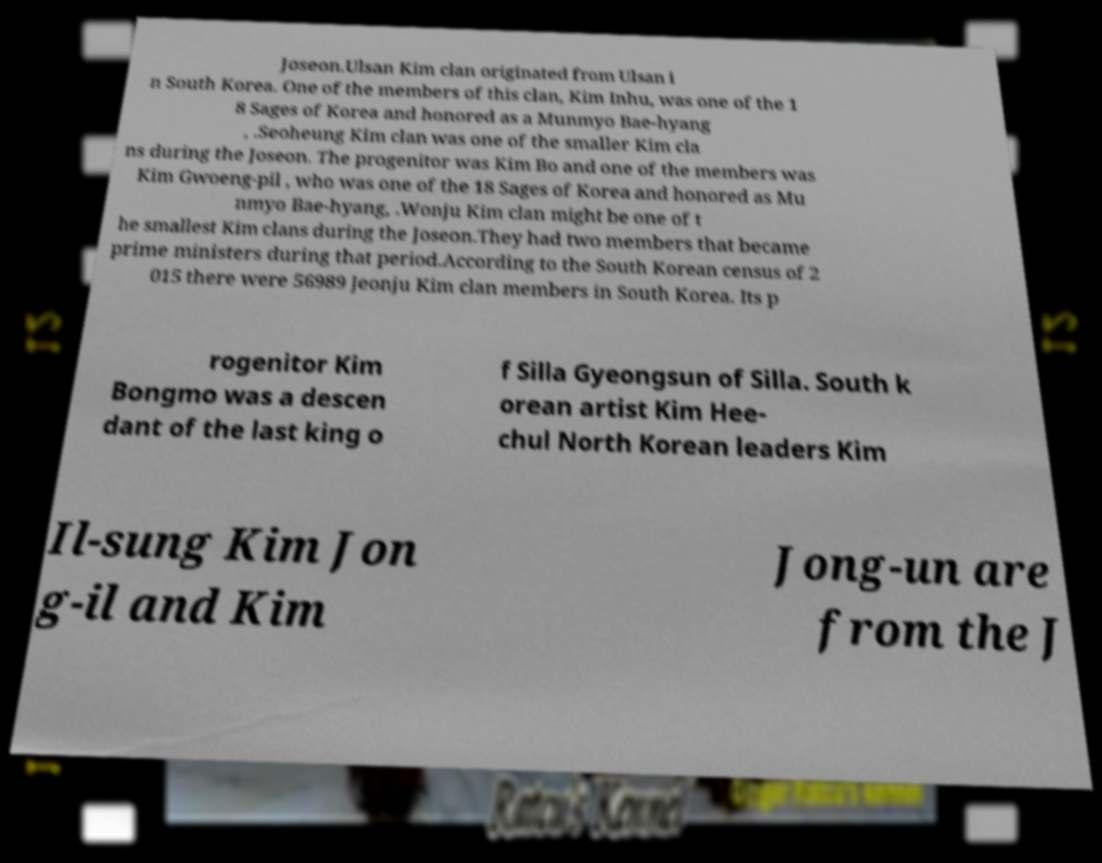For documentation purposes, I need the text within this image transcribed. Could you provide that? Joseon.Ulsan Kim clan originated from Ulsan i n South Korea. One of the members of this clan, Kim Inhu, was one of the 1 8 Sages of Korea and honored as a Munmyo Bae-hyang , .Seoheung Kim clan was one of the smaller Kim cla ns during the Joseon. The progenitor was Kim Bo and one of the members was Kim Gwoeng-pil , who was one of the 18 Sages of Korea and honored as Mu nmyo Bae-hyang, .Wonju Kim clan might be one of t he smallest Kim clans during the Joseon.They had two members that became prime ministers during that period.According to the South Korean census of 2 015 there were 56989 Jeonju Kim clan members in South Korea. Its p rogenitor Kim Bongmo was a descen dant of the last king o f Silla Gyeongsun of Silla. South k orean artist Kim Hee- chul North Korean leaders Kim Il-sung Kim Jon g-il and Kim Jong-un are from the J 